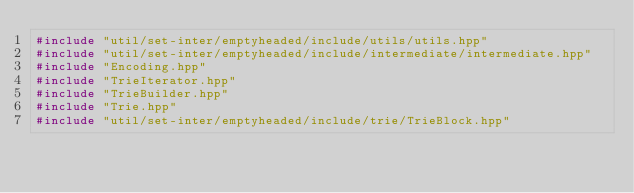Convert code to text. <code><loc_0><loc_0><loc_500><loc_500><_C++_>#include "util/set-inter/emptyheaded/include/utils/utils.hpp"
#include "util/set-inter/emptyheaded/include/intermediate/intermediate.hpp"
#include "Encoding.hpp"
#include "TrieIterator.hpp"
#include "TrieBuilder.hpp"
#include "Trie.hpp"
#include "util/set-inter/emptyheaded/include/trie/TrieBlock.hpp"</code> 